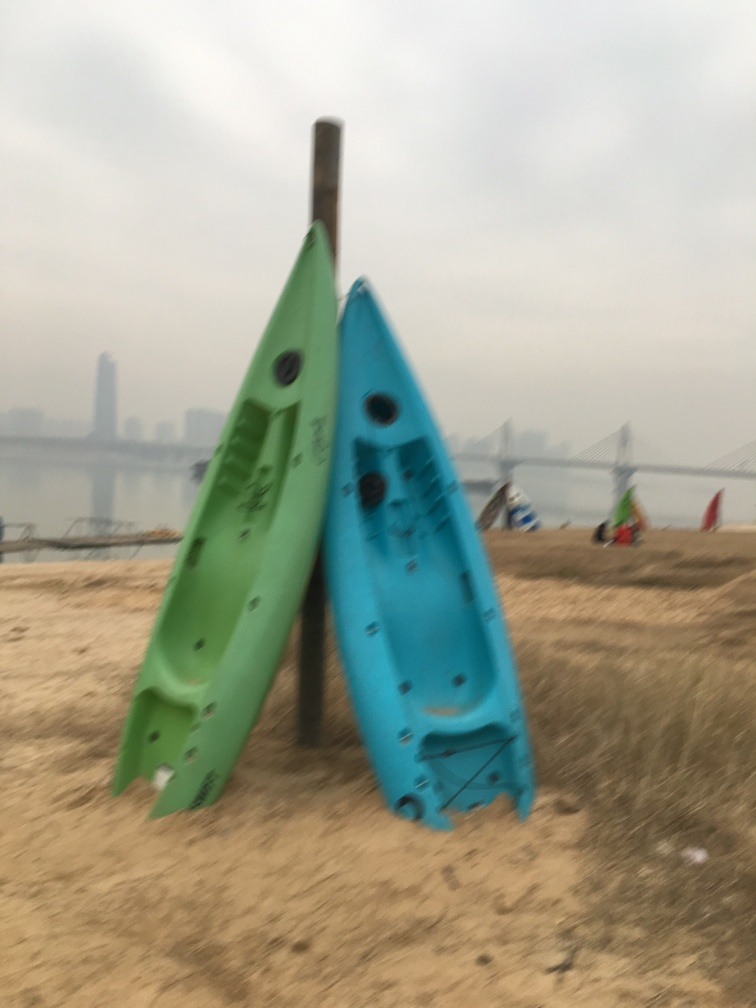How does the atmosphere of the photo affect the mood it conveys? The hazy sky and the subdued color palette give this photo a serene, almost contemplative mood. It suggests stillness, as if the activities typically associated with the boats are on pause, possibly due to the off-season or the time of day. The faint silhouette of the bridge and city skyline in the background adds a contrasting element of urban life in the distance. 